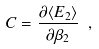<formula> <loc_0><loc_0><loc_500><loc_500>C = \frac { \partial \langle E _ { 2 } \rangle } { \partial \beta _ { 2 } } \ ,</formula> 